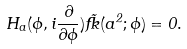<formula> <loc_0><loc_0><loc_500><loc_500>H _ { a } ( \phi , i \frac { \partial } { \partial \phi } ) \tilde { \Psi } ( a ^ { 2 } ; \phi ) = 0 .</formula> 